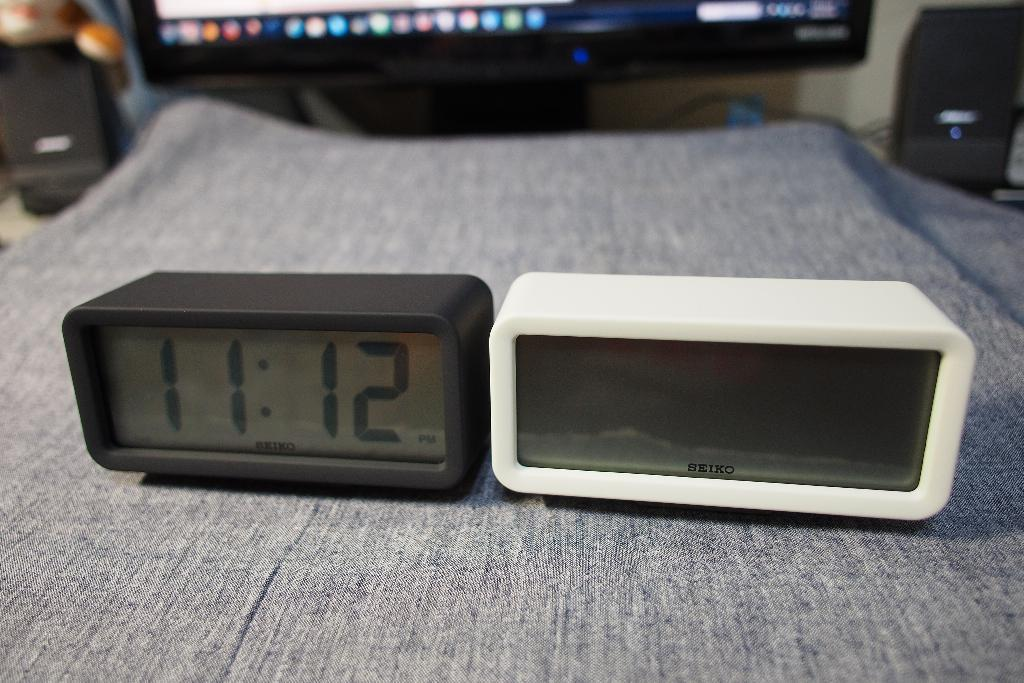<image>
Present a compact description of the photo's key features. the time of 11:12 is on an alarm 